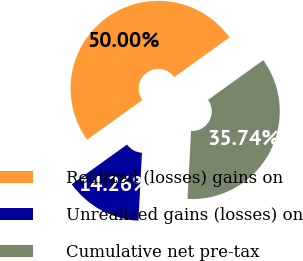Convert chart to OTSL. <chart><loc_0><loc_0><loc_500><loc_500><pie_chart><fcel>Realized (losses) gains on<fcel>Unrealized gains (losses) on<fcel>Cumulative net pre-tax<nl><fcel>50.0%<fcel>14.26%<fcel>35.74%<nl></chart> 